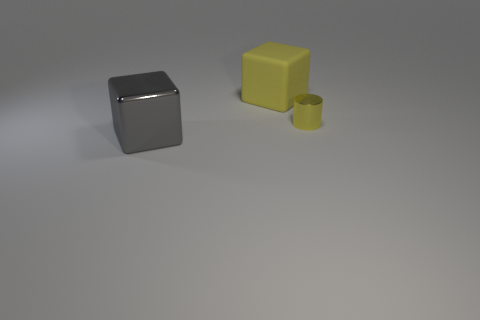Which of the objects in this image reflects the most light? The silver cube reflects the most light due to its shiny, metallic surface. 